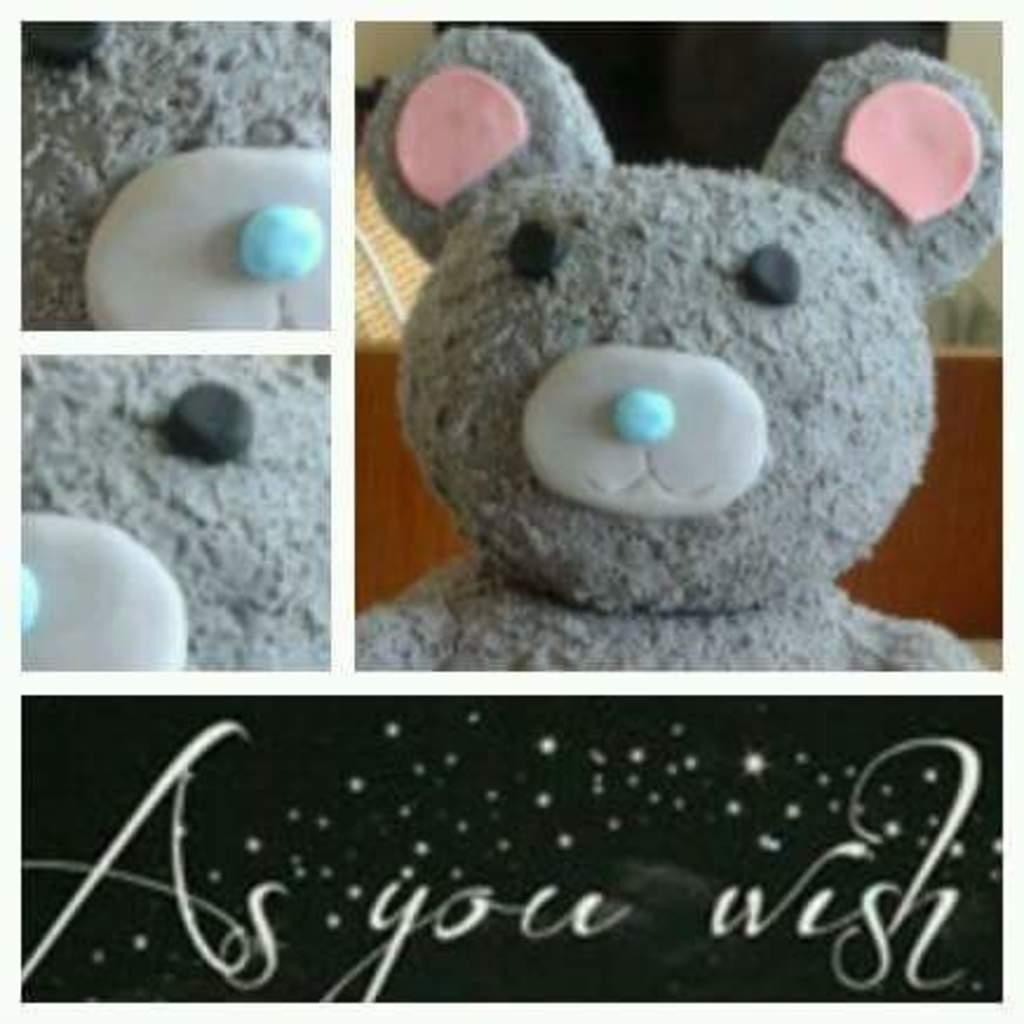What type of composition is the image? The image is a collage of four images. What is the common theme among most of the images? Three of the images contain teddy bears. Are there any images with text in the collage? Yes, one of the images contains text. What type of loaf is being sliced in the image? There is no loaf present in the image; it is a collage of images featuring teddy bears and text. 